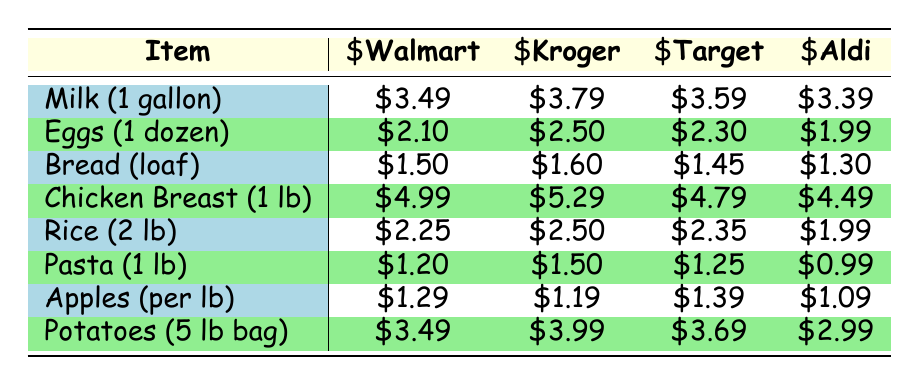What's the price of a dozen eggs at Aldi? The table shows the price for each item at various stores. For Aldi, the price for Eggs (1 dozen) is listed as 1.99.
Answer: 1.99 Which store has the highest price for chicken breast? Looking at the prices specifically for Chicken Breast (1 lb), Kroger has the highest price at 5.29.
Answer: Kroger What is the difference in price for a loaf of bread between Walmart and Aldi? The price for Bread (loaf) at Walmart is 1.50 and at Aldi is 1.30. The difference is calculated as 1.50 - 1.30 = 0.20.
Answer: 0.20 Is Target's price for milk higher than Aldi's? The price for Milk (1 gallon) at Target is 3.59 and at Aldi is 3.39. Since 3.59 is greater than 3.39, the statement is true.
Answer: Yes What is the average price of potatoes across all four stores? The prices for Potatoes (5 lb bag) are: Walmart 3.49, Kroger 3.99, Target 3.69, and Aldi 2.99. The total is 3.49 + 3.99 + 3.69 + 2.99 = 14.16. There are 4 prices, so the average is 14.16 / 4 = 3.54.
Answer: 3.54 Which store offers the lowest price on rice? The prices for Rice (2 lb) are Walmart at 2.25, Kroger at 2.50, Target at 2.35, and Aldi at 1.99. Aldi has the lowest price at 1.99.
Answer: Aldi How much more does Kroger charge for a gallon of milk compared to Aldi? At Kroger, Milk (1 gallon) costs 3.79, and at Aldi it's 3.39. The difference is calculated as 3.79 - 3.39 = 0.40.
Answer: 0.40 Which fruit is the most expensive per pound at Kroger? The only fruit listed is Apples (per lb) with a price of 1.19. Since it's the only fruit price given, it is the most expensive.
Answer: Yes What item has the largest price difference between Walmart and Aldi? Comparing the prices of Chicken Breast (1 lb) with Walmart at 4.99 and Aldi at 4.49 gives a difference of 4.99 - 4.49 = 0.50. This is the largest difference for the items listed.
Answer: 0.50 